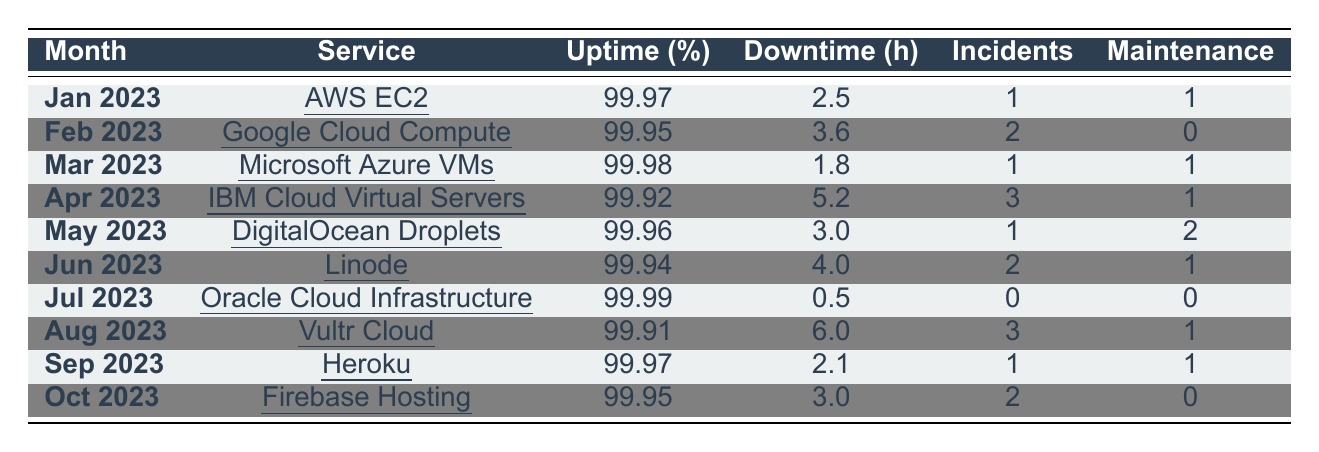What is the uptime percentage for Oracle Cloud Infrastructure in July 2023? The table shows that the uptime percentage for Oracle Cloud Infrastructure for July 2023 is 99.99%.
Answer: 99.99% How many maintenance windows were recorded for IBM Cloud Virtual Servers in April 2023? The entry for IBM Cloud Virtual Servers in April 2023 indicates there was 1 maintenance window.
Answer: 1 What is the total downtime hours for DigitalOcean Droplets and Heroku combined? The downtime hours for DigitalOcean Droplets is 3.0, and for Heroku, it is 2.1. Thus, combining these gives 3.0 + 2.1 = 5.1 hours.
Answer: 5.1 Which service had the highest uptime percentage in March 2023? The table lists Microsoft Azure Virtual Machines with an uptime percentage of 99.98% for March 2023, which is the highest in that month.
Answer: Microsoft Azure Virtual Machines Was there any month where the downtime hours exceeded 6 hours? By checking all entries, the maximum downtime recorded is 6.0 hours for Vultr Cloud in August 2023, but no month exceeded that. Therefore, the answer is no.
Answer: No Calculate the average uptime percentage for all services in the table. Adding the uptime percentages: 99.97 + 99.95 + 99.98 + 99.92 + 99.96 + 99.94 + 99.99 + 99.91 + 99.97 + 99.95 = 999.75. There are 10 services, so the average is 999.75 / 10 = 99.975%.
Answer: 99.975% How many total incidents were recorded across all months for Google Cloud Compute and IBM Cloud Virtual Servers combined? Google Cloud Compute had 2 incidents in February 2023, and IBM Cloud Virtual Servers had 3 incidents in April 2023. Adding these gives 2 + 3 = 5 incidents combined.
Answer: 5 Which service had the least amount of downtime hours? The table shows Oracle Cloud Infrastructure with 0.5 hours of downtime in July 2023, making it the service with the least downtime.
Answer: Oracle Cloud Infrastructure Is the uptime percentage for Firebase Hosting higher than that for DigitalOcean Droplets? Firebase Hosting has an uptime of 99.95%, while DigitalOcean Droplets has an uptime of 99.96%. Since 99.95% is less than 99.96%, the answer is no.
Answer: No What was the month with the most incidents recorded? The table indicates that IBM Cloud Virtual Servers in April 2023 and Vultr Cloud in August 2023 both had the highest number of incidents at 3.
Answer: April 2023 and August 2023 Identify the service with the longest downtime in June 2023. In June 2023, Linode experienced 4.0 hours of downtime, which is longer than any other service listed for that month.
Answer: Linode 